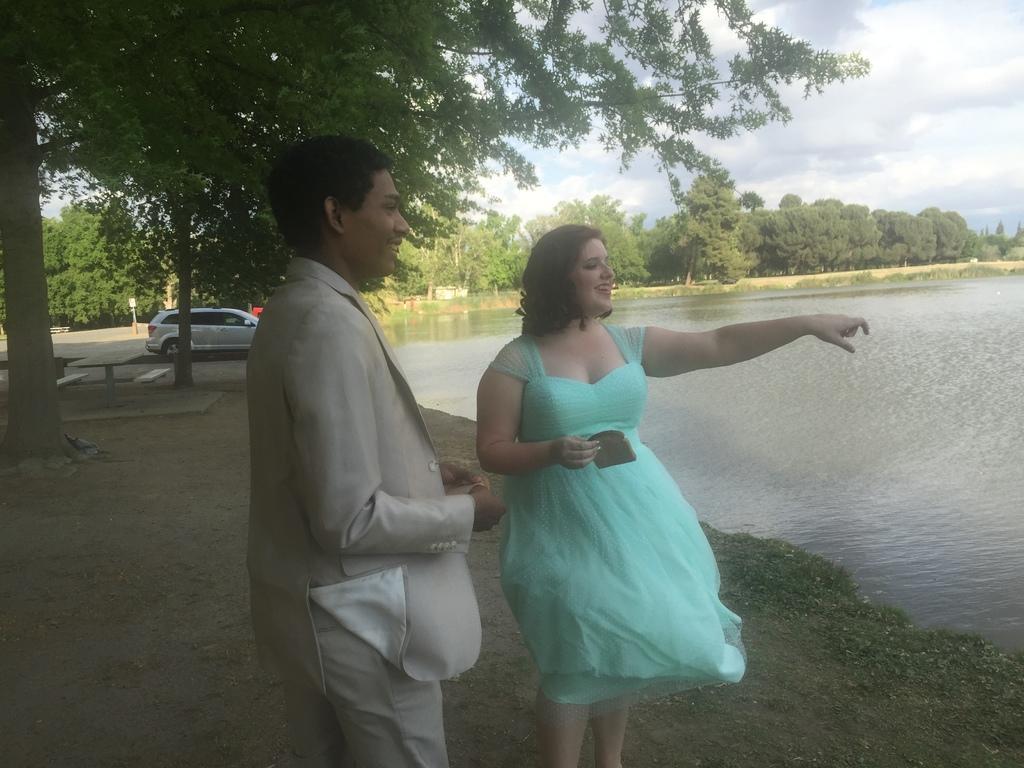How would you summarize this image in a sentence or two? In this picture there is a woman who is wearing dress and holding a bread, beside her there is a man who is wearing suit and trouser. He is also holding a bread and both of them are smiling. On the right i can see the water. On the left i can see the table, bench, road, basketball court and car. In the background i can see the trees, plants and grass. In the top right i can see the sky and clouds. 